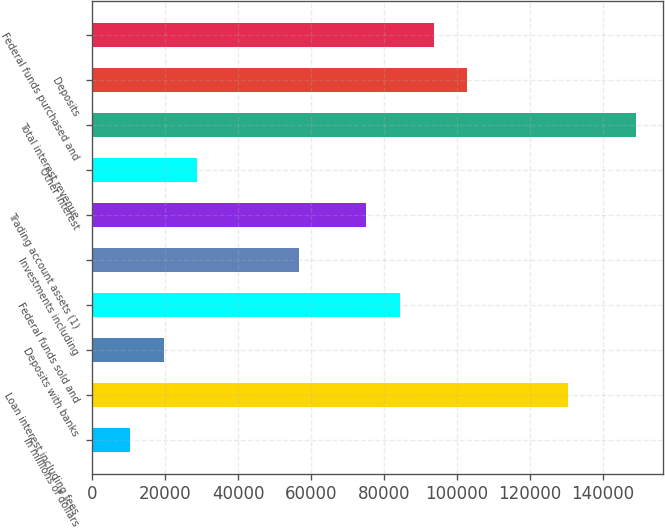Convert chart. <chart><loc_0><loc_0><loc_500><loc_500><bar_chart><fcel>In millions of dollars<fcel>Loan interest including fees<fcel>Deposits with banks<fcel>Federal funds sold and<fcel>Investments including<fcel>Trading account assets (1)<fcel>Other interest<fcel>Total interest revenue<fcel>Deposits<fcel>Federal funds purchased and<nl><fcel>10368.2<fcel>130608<fcel>19617.4<fcel>84361.8<fcel>56614.2<fcel>75112.6<fcel>28866.6<fcel>149106<fcel>102860<fcel>93611<nl></chart> 